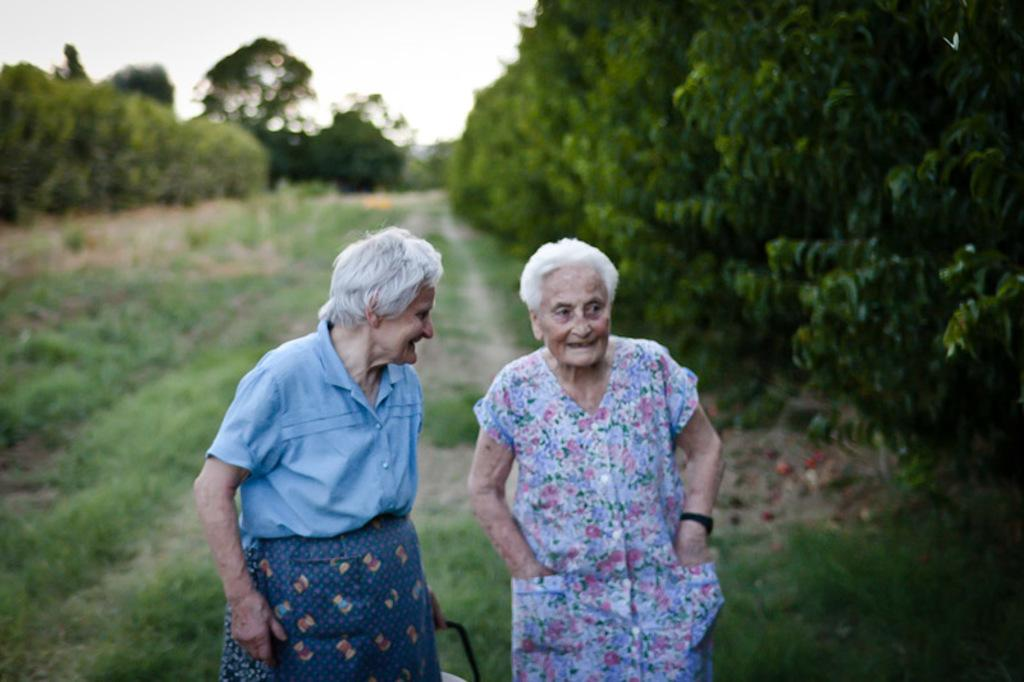Who are the main subjects in the image? There are two women in the center of the image. What can be seen in the background of the image? There are trees in the background of the image. What type of vegetation is visible at the bottom of the image? There is grass at the bottom of the image. What historical event is being commemorated by the two women in the image? There is no indication of a historical event being commemorated in the image; it simply features two women in the center. 